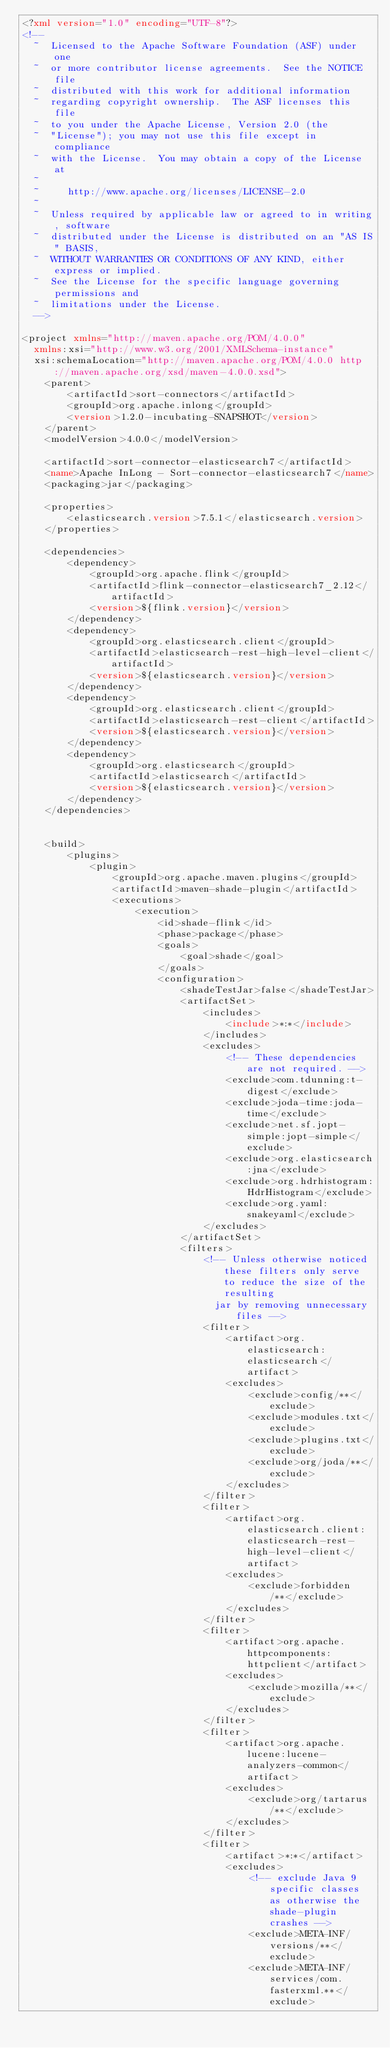<code> <loc_0><loc_0><loc_500><loc_500><_XML_><?xml version="1.0" encoding="UTF-8"?>
<!--
  ~  Licensed to the Apache Software Foundation (ASF) under one
  ~  or more contributor license agreements.  See the NOTICE file
  ~  distributed with this work for additional information
  ~  regarding copyright ownership.  The ASF licenses this file
  ~  to you under the Apache License, Version 2.0 (the
  ~  "License"); you may not use this file except in compliance
  ~  with the License.  You may obtain a copy of the License at
  ~
  ~     http://www.apache.org/licenses/LICENSE-2.0
  ~
  ~  Unless required by applicable law or agreed to in writing, software
  ~  distributed under the License is distributed on an "AS IS" BASIS,
  ~  WITHOUT WARRANTIES OR CONDITIONS OF ANY KIND, either express or implied.
  ~  See the License for the specific language governing permissions and
  ~  limitations under the License.
  -->

<project xmlns="http://maven.apache.org/POM/4.0.0"
  xmlns:xsi="http://www.w3.org/2001/XMLSchema-instance"
  xsi:schemaLocation="http://maven.apache.org/POM/4.0.0 http://maven.apache.org/xsd/maven-4.0.0.xsd">
    <parent>
        <artifactId>sort-connectors</artifactId>
        <groupId>org.apache.inlong</groupId>
        <version>1.2.0-incubating-SNAPSHOT</version>
    </parent>
    <modelVersion>4.0.0</modelVersion>

    <artifactId>sort-connector-elasticsearch7</artifactId>
    <name>Apache InLong - Sort-connector-elasticsearch7</name>
    <packaging>jar</packaging>

    <properties>
        <elasticsearch.version>7.5.1</elasticsearch.version>
    </properties>

    <dependencies>
        <dependency>
            <groupId>org.apache.flink</groupId>
            <artifactId>flink-connector-elasticsearch7_2.12</artifactId>
            <version>${flink.version}</version>
        </dependency>
        <dependency>
            <groupId>org.elasticsearch.client</groupId>
            <artifactId>elasticsearch-rest-high-level-client</artifactId>
            <version>${elasticsearch.version}</version>
        </dependency>
        <dependency>
            <groupId>org.elasticsearch.client</groupId>
            <artifactId>elasticsearch-rest-client</artifactId>
            <version>${elasticsearch.version}</version>
        </dependency>
        <dependency>
            <groupId>org.elasticsearch</groupId>
            <artifactId>elasticsearch</artifactId>
            <version>${elasticsearch.version}</version>
        </dependency>
    </dependencies>


    <build>
        <plugins>
            <plugin>
                <groupId>org.apache.maven.plugins</groupId>
                <artifactId>maven-shade-plugin</artifactId>
                <executions>
                    <execution>
                        <id>shade-flink</id>
                        <phase>package</phase>
                        <goals>
                            <goal>shade</goal>
                        </goals>
                        <configuration>
                            <shadeTestJar>false</shadeTestJar>
                            <artifactSet>
                                <includes>
                                    <include>*:*</include>
                                </includes>
                                <excludes>
                                    <!-- These dependencies are not required. -->
                                    <exclude>com.tdunning:t-digest</exclude>
                                    <exclude>joda-time:joda-time</exclude>
                                    <exclude>net.sf.jopt-simple:jopt-simple</exclude>
                                    <exclude>org.elasticsearch:jna</exclude>
                                    <exclude>org.hdrhistogram:HdrHistogram</exclude>
                                    <exclude>org.yaml:snakeyaml</exclude>
                                </excludes>
                            </artifactSet>
                            <filters>
                                <!-- Unless otherwise noticed these filters only serve to reduce the size of the resulting
                                  jar by removing unnecessary files -->
                                <filter>
                                    <artifact>org.elasticsearch:elasticsearch</artifact>
                                    <excludes>
                                        <exclude>config/**</exclude>
                                        <exclude>modules.txt</exclude>
                                        <exclude>plugins.txt</exclude>
                                        <exclude>org/joda/**</exclude>
                                    </excludes>
                                </filter>
                                <filter>
                                    <artifact>org.elasticsearch.client:elasticsearch-rest-high-level-client</artifact>
                                    <excludes>
                                        <exclude>forbidden/**</exclude>
                                    </excludes>
                                </filter>
                                <filter>
                                    <artifact>org.apache.httpcomponents:httpclient</artifact>
                                    <excludes>
                                        <exclude>mozilla/**</exclude>
                                    </excludes>
                                </filter>
                                <filter>
                                    <artifact>org.apache.lucene:lucene-analyzers-common</artifact>
                                    <excludes>
                                        <exclude>org/tartarus/**</exclude>
                                    </excludes>
                                </filter>
                                <filter>
                                    <artifact>*:*</artifact>
                                    <excludes>
                                        <!-- exclude Java 9 specific classes as otherwise the shade-plugin crashes -->
                                        <exclude>META-INF/versions/**</exclude>
                                        <exclude>META-INF/services/com.fasterxml.**</exclude></code> 